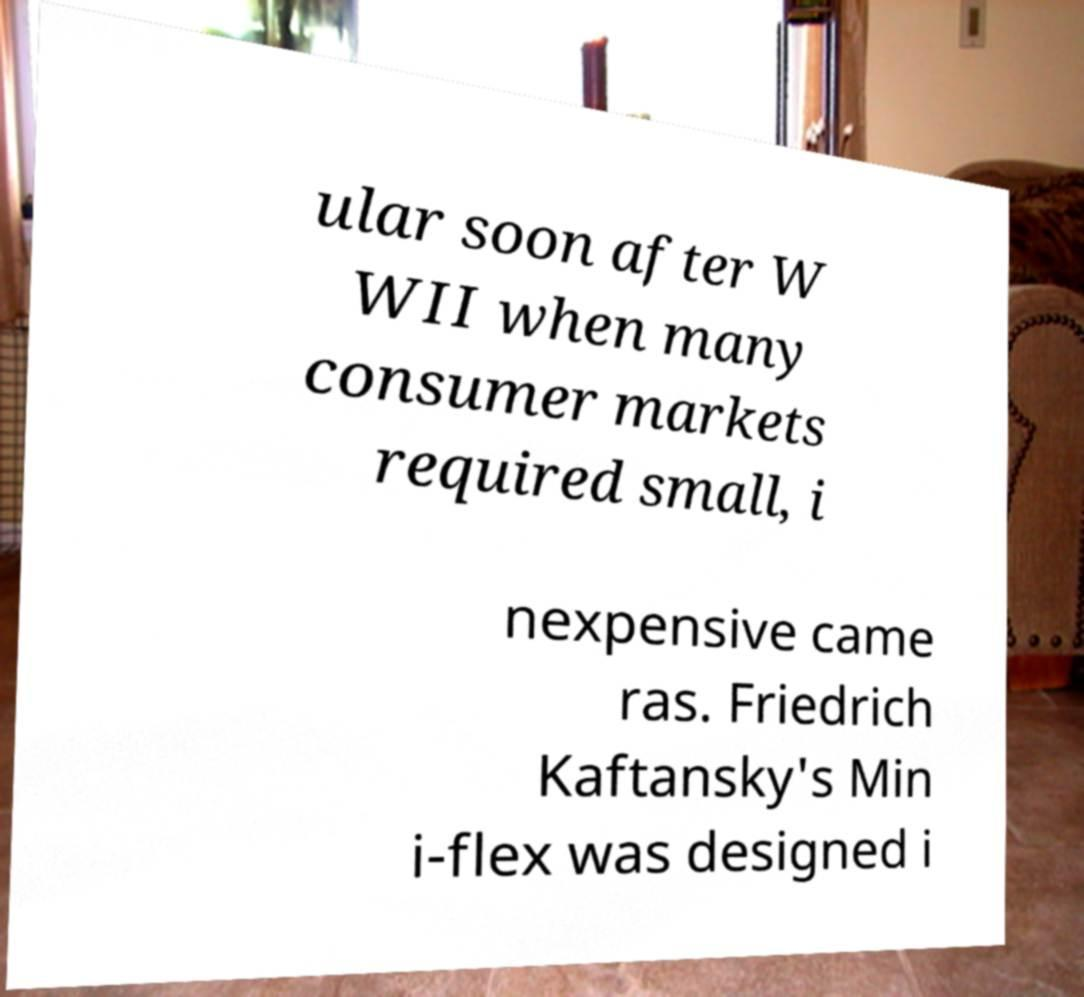Could you assist in decoding the text presented in this image and type it out clearly? ular soon after W WII when many consumer markets required small, i nexpensive came ras. Friedrich Kaftansky's Min i-flex was designed i 